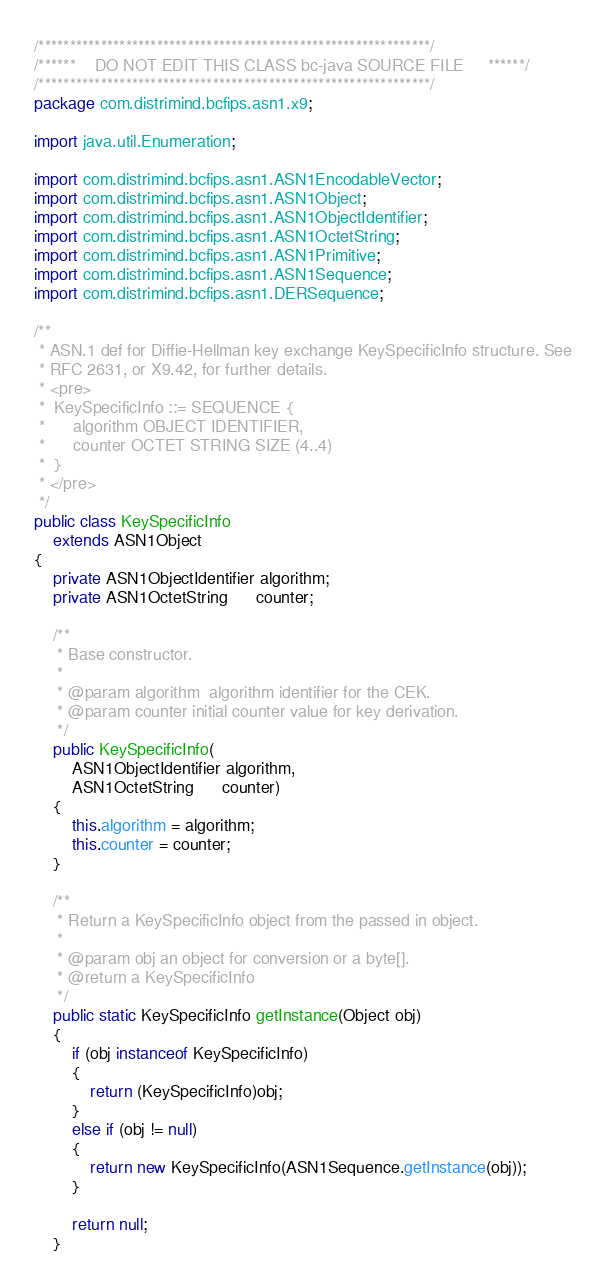<code> <loc_0><loc_0><loc_500><loc_500><_Java_>/***************************************************************/
/******    DO NOT EDIT THIS CLASS bc-java SOURCE FILE     ******/
/***************************************************************/
package com.distrimind.bcfips.asn1.x9;

import java.util.Enumeration;

import com.distrimind.bcfips.asn1.ASN1EncodableVector;
import com.distrimind.bcfips.asn1.ASN1Object;
import com.distrimind.bcfips.asn1.ASN1ObjectIdentifier;
import com.distrimind.bcfips.asn1.ASN1OctetString;
import com.distrimind.bcfips.asn1.ASN1Primitive;
import com.distrimind.bcfips.asn1.ASN1Sequence;
import com.distrimind.bcfips.asn1.DERSequence;

/**
 * ASN.1 def for Diffie-Hellman key exchange KeySpecificInfo structure. See
 * RFC 2631, or X9.42, for further details.
 * <pre>
 *  KeySpecificInfo ::= SEQUENCE {
 *      algorithm OBJECT IDENTIFIER,
 *      counter OCTET STRING SIZE (4..4)
 *  }
 * </pre>
 */
public class KeySpecificInfo
    extends ASN1Object
{
    private ASN1ObjectIdentifier algorithm;
    private ASN1OctetString      counter;

    /**
     * Base constructor.
     *
     * @param algorithm  algorithm identifier for the CEK.
     * @param counter initial counter value for key derivation.
     */
    public KeySpecificInfo(
        ASN1ObjectIdentifier algorithm,
        ASN1OctetString      counter)
    {
        this.algorithm = algorithm;
        this.counter = counter;
    }

    /**
     * Return a KeySpecificInfo object from the passed in object.
     *
     * @param obj an object for conversion or a byte[].
     * @return a KeySpecificInfo
     */
    public static KeySpecificInfo getInstance(Object obj)
    {
        if (obj instanceof KeySpecificInfo)
        {
            return (KeySpecificInfo)obj;
        }
        else if (obj != null)
        {
            return new KeySpecificInfo(ASN1Sequence.getInstance(obj));
        }

        return null;
    }
</code> 